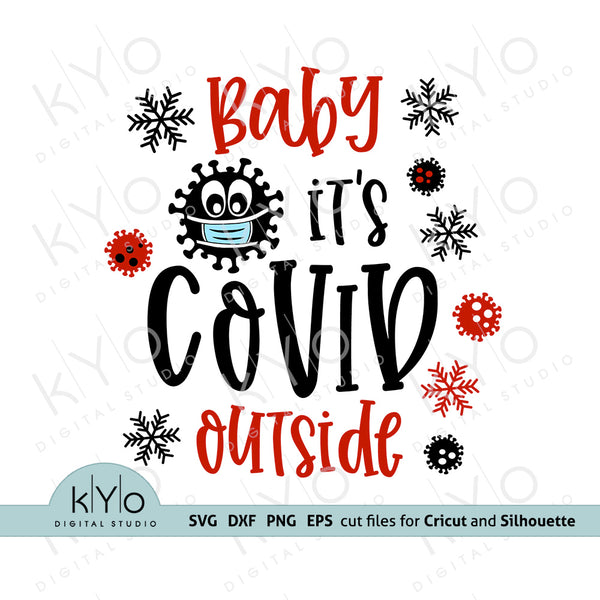In what ways does this image interact with holiday traditions and sentiments? This image ingeniously interweaves the stark reality of the COVID-19 pandemic with traditional holiday sentiments. By altering the lyrics to a popular holiday song, it creates a resonance with familiar festive elements while simultaneously capturing the unique circumstances of the holiday season during a global pandemic. The use of snowflakes and festive colors maintains the cheer associated with the season, yet the masked virus particle is a clear nod to the ongoing health precautions. It's a clever juxtaposition that highlights how traditions have adapted to current events, reflecting resilience and the capacity to find joy and humor even in challenging times. 